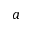<formula> <loc_0><loc_0><loc_500><loc_500>a</formula> 